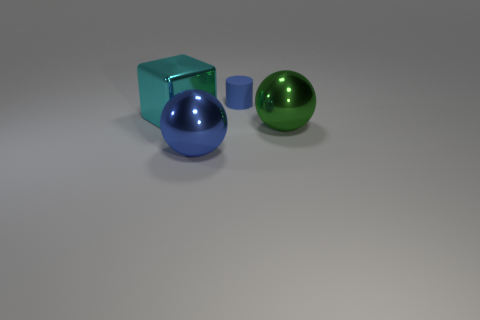Add 3 brown spheres. How many objects exist? 7 Subtract all cylinders. How many objects are left? 3 Subtract 0 red cylinders. How many objects are left? 4 Subtract all tiny blue matte things. Subtract all small blue matte objects. How many objects are left? 2 Add 3 cyan metal cubes. How many cyan metal cubes are left? 4 Add 2 tiny gray matte spheres. How many tiny gray matte spheres exist? 2 